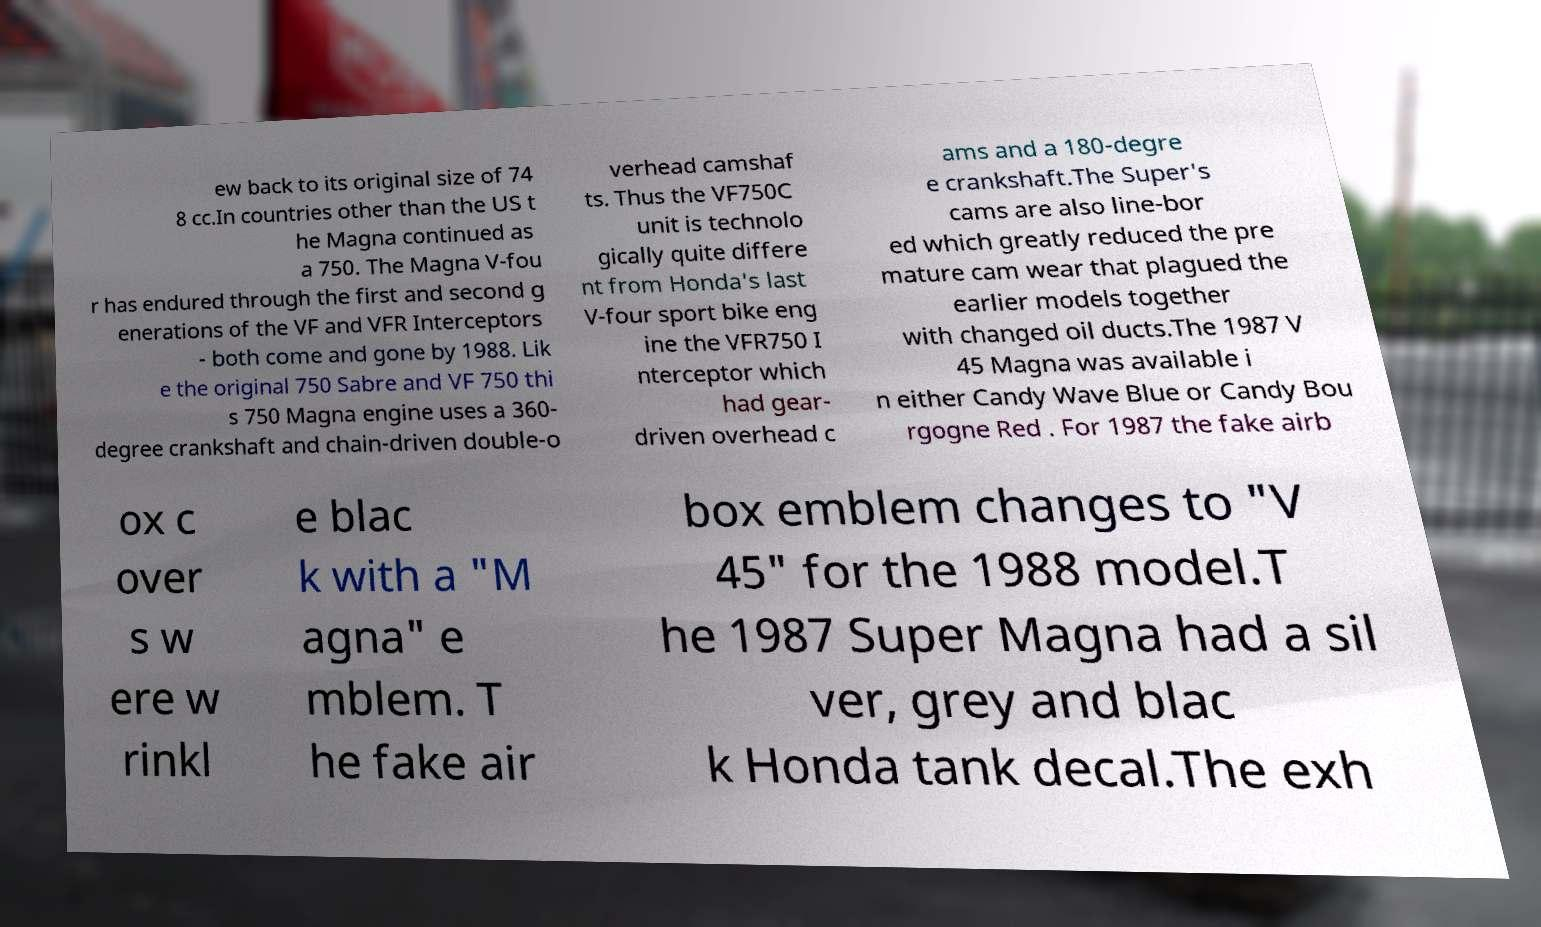Could you assist in decoding the text presented in this image and type it out clearly? ew back to its original size of 74 8 cc.In countries other than the US t he Magna continued as a 750. The Magna V-fou r has endured through the first and second g enerations of the VF and VFR Interceptors - both come and gone by 1988. Lik e the original 750 Sabre and VF 750 thi s 750 Magna engine uses a 360- degree crankshaft and chain-driven double-o verhead camshaf ts. Thus the VF750C unit is technolo gically quite differe nt from Honda's last V-four sport bike eng ine the VFR750 I nterceptor which had gear- driven overhead c ams and a 180-degre e crankshaft.The Super's cams are also line-bor ed which greatly reduced the pre mature cam wear that plagued the earlier models together with changed oil ducts.The 1987 V 45 Magna was available i n either Candy Wave Blue or Candy Bou rgogne Red . For 1987 the fake airb ox c over s w ere w rinkl e blac k with a "M agna" e mblem. T he fake air box emblem changes to "V 45" for the 1988 model.T he 1987 Super Magna had a sil ver, grey and blac k Honda tank decal.The exh 